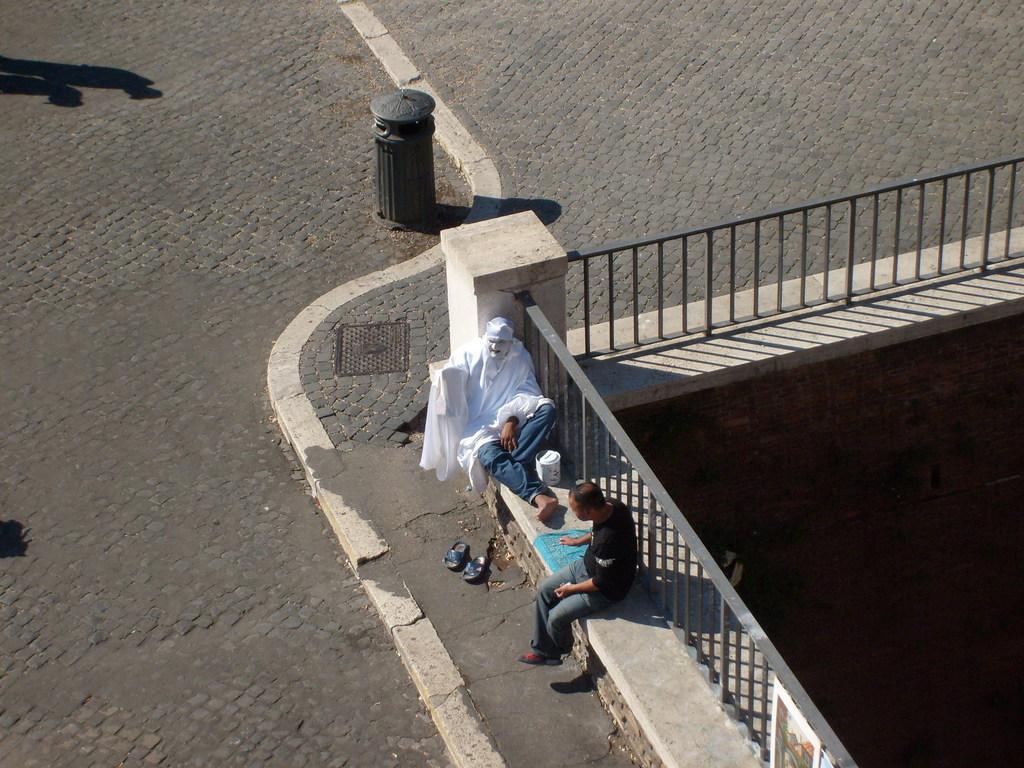Please provide a concise description of this image. In this image in front there are two people sitting on the platform. Behind them there is a metal fence. In front of them there is a road. There is a dustbin. On the right side of the image there is a wall. 